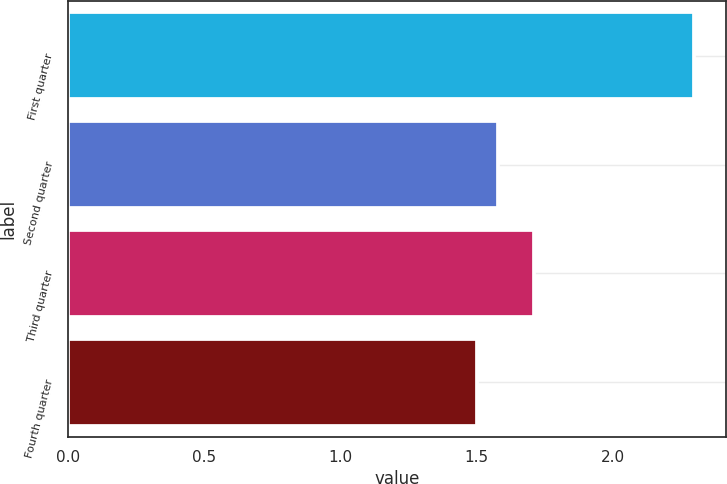Convert chart. <chart><loc_0><loc_0><loc_500><loc_500><bar_chart><fcel>First quarter<fcel>Second quarter<fcel>Third quarter<fcel>Fourth quarter<nl><fcel>2.3<fcel>1.58<fcel>1.71<fcel>1.5<nl></chart> 